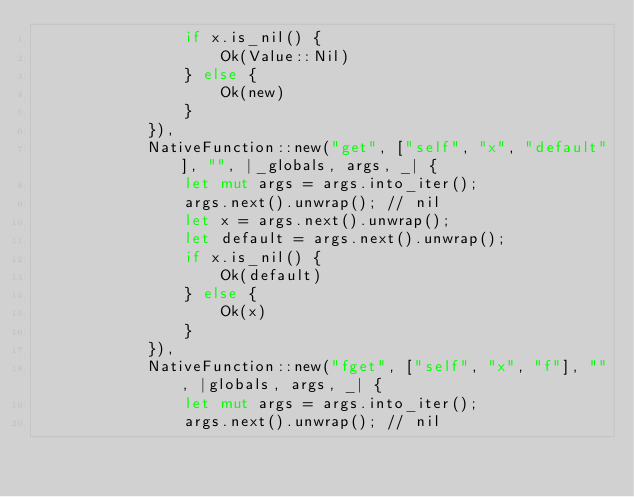Convert code to text. <code><loc_0><loc_0><loc_500><loc_500><_Rust_>                if x.is_nil() {
                    Ok(Value::Nil)
                } else {
                    Ok(new)
                }
            }),
            NativeFunction::new("get", ["self", "x", "default"], "", |_globals, args, _| {
                let mut args = args.into_iter();
                args.next().unwrap(); // nil
                let x = args.next().unwrap();
                let default = args.next().unwrap();
                if x.is_nil() {
                    Ok(default)
                } else {
                    Ok(x)
                }
            }),
            NativeFunction::new("fget", ["self", "x", "f"], "", |globals, args, _| {
                let mut args = args.into_iter();
                args.next().unwrap(); // nil</code> 